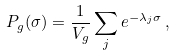<formula> <loc_0><loc_0><loc_500><loc_500>P _ { g } ( \sigma ) = \frac { 1 } { V _ { g } } \sum _ { j } e ^ { - \lambda _ { j } \sigma } \, ,</formula> 